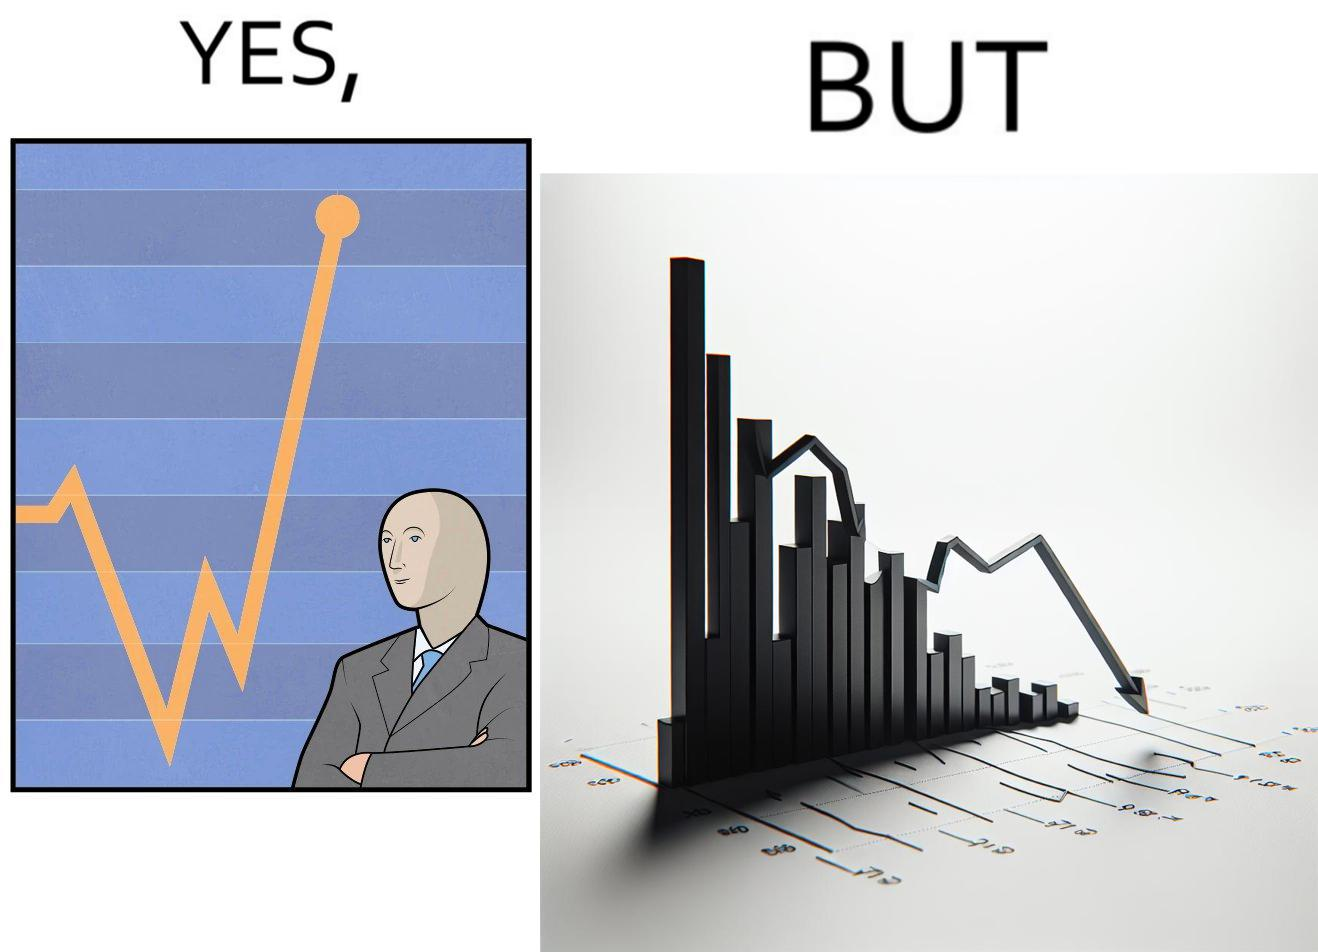Describe what you see in this image. The image is ironic, because a person is seen feeling proud over the profit earned over his investment but the right image shows the whole story how only a small part of his investment journey is shown and the other loss part is ignored 